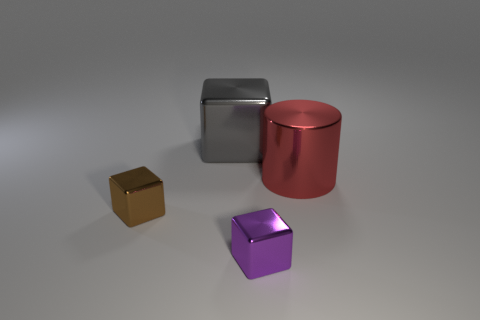There is a big thing that is on the right side of the tiny block to the right of the large gray cube; what is its color?
Your answer should be compact. Red. Is there another large cube of the same color as the large metallic cube?
Your answer should be very brief. No. What is the size of the gray cube that is behind the tiny shiny thing that is behind the small metallic cube in front of the brown shiny thing?
Offer a very short reply. Large. What is the shape of the big red metallic object?
Ensure brevity in your answer.  Cylinder. There is a big metal object to the right of the purple metallic thing; how many metal blocks are right of it?
Your response must be concise. 0. What number of other objects are there of the same material as the cylinder?
Keep it short and to the point. 3. Does the big thing on the left side of the red object have the same material as the tiny cube right of the brown shiny block?
Provide a succinct answer. Yes. Is there anything else that has the same shape as the big red object?
Make the answer very short. No. Do the small purple block and the tiny block left of the small purple cube have the same material?
Ensure brevity in your answer.  Yes. What is the color of the tiny cube that is behind the metal cube right of the large object to the left of the red shiny thing?
Provide a succinct answer. Brown. 